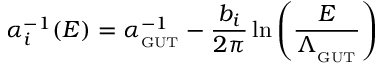<formula> <loc_0><loc_0><loc_500><loc_500>\alpha _ { i } ^ { - 1 } ( E ) = \alpha _ { _ { G } U T } ^ { - 1 } - \frac { b _ { i } } { 2 \pi } \ln \left ( \frac { E } { \Lambda _ { _ { G } U T } } \right )</formula> 